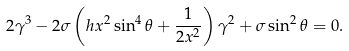<formula> <loc_0><loc_0><loc_500><loc_500>2 \gamma ^ { 3 } - 2 \sigma \left ( h x ^ { 2 } \sin ^ { 4 } \theta + \frac { 1 } { 2 x ^ { 2 } } \right ) \gamma ^ { 2 } + \sigma \sin ^ { 2 } \theta = 0 .</formula> 